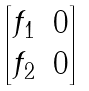<formula> <loc_0><loc_0><loc_500><loc_500>\begin{bmatrix} f _ { 1 } & 0 \\ f _ { 2 } & 0 \end{bmatrix}</formula> 